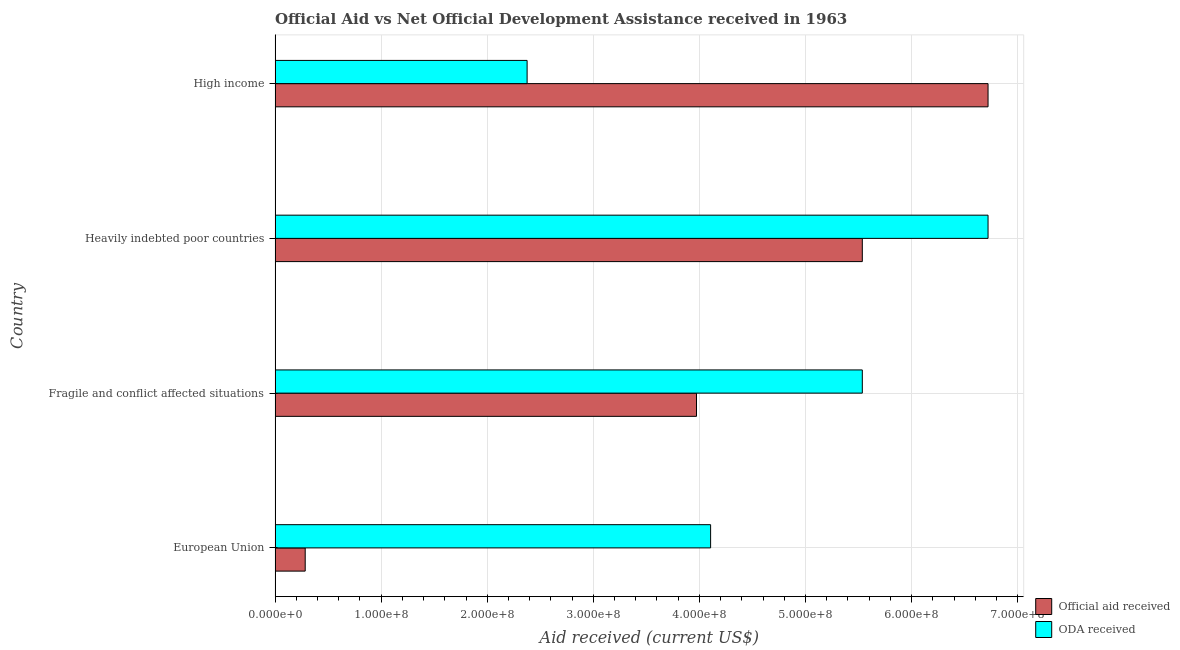How many groups of bars are there?
Your response must be concise. 4. How many bars are there on the 2nd tick from the top?
Give a very brief answer. 2. What is the label of the 3rd group of bars from the top?
Ensure brevity in your answer.  Fragile and conflict affected situations. In how many cases, is the number of bars for a given country not equal to the number of legend labels?
Your answer should be very brief. 0. What is the official aid received in Fragile and conflict affected situations?
Provide a succinct answer. 3.97e+08. Across all countries, what is the maximum oda received?
Offer a terse response. 6.72e+08. Across all countries, what is the minimum oda received?
Give a very brief answer. 2.38e+08. In which country was the official aid received maximum?
Your answer should be compact. High income. What is the total oda received in the graph?
Give a very brief answer. 1.87e+09. What is the difference between the oda received in Fragile and conflict affected situations and that in Heavily indebted poor countries?
Your answer should be very brief. -1.19e+08. What is the difference between the oda received in Heavily indebted poor countries and the official aid received in Fragile and conflict affected situations?
Your answer should be very brief. 2.75e+08. What is the average official aid received per country?
Offer a terse response. 4.13e+08. What is the difference between the official aid received and oda received in Heavily indebted poor countries?
Provide a short and direct response. -1.19e+08. What is the ratio of the oda received in Fragile and conflict affected situations to that in Heavily indebted poor countries?
Give a very brief answer. 0.82. Is the oda received in Heavily indebted poor countries less than that in High income?
Offer a very short reply. No. What is the difference between the highest and the second highest official aid received?
Offer a terse response. 1.19e+08. What is the difference between the highest and the lowest oda received?
Give a very brief answer. 4.34e+08. Is the sum of the oda received in European Union and Heavily indebted poor countries greater than the maximum official aid received across all countries?
Your answer should be very brief. Yes. What does the 2nd bar from the top in High income represents?
Give a very brief answer. Official aid received. What does the 1st bar from the bottom in Fragile and conflict affected situations represents?
Offer a terse response. Official aid received. Are all the bars in the graph horizontal?
Offer a terse response. Yes. How many countries are there in the graph?
Your answer should be very brief. 4. Does the graph contain any zero values?
Provide a succinct answer. No. What is the title of the graph?
Keep it short and to the point. Official Aid vs Net Official Development Assistance received in 1963 . Does "Register a property" appear as one of the legend labels in the graph?
Your answer should be very brief. No. What is the label or title of the X-axis?
Your answer should be very brief. Aid received (current US$). What is the label or title of the Y-axis?
Provide a short and direct response. Country. What is the Aid received (current US$) of Official aid received in European Union?
Offer a terse response. 2.84e+07. What is the Aid received (current US$) in ODA received in European Union?
Ensure brevity in your answer.  4.11e+08. What is the Aid received (current US$) in Official aid received in Fragile and conflict affected situations?
Make the answer very short. 3.97e+08. What is the Aid received (current US$) of ODA received in Fragile and conflict affected situations?
Make the answer very short. 5.54e+08. What is the Aid received (current US$) in Official aid received in Heavily indebted poor countries?
Your answer should be compact. 5.54e+08. What is the Aid received (current US$) in ODA received in Heavily indebted poor countries?
Keep it short and to the point. 6.72e+08. What is the Aid received (current US$) of Official aid received in High income?
Keep it short and to the point. 6.72e+08. What is the Aid received (current US$) in ODA received in High income?
Keep it short and to the point. 2.38e+08. Across all countries, what is the maximum Aid received (current US$) in Official aid received?
Your response must be concise. 6.72e+08. Across all countries, what is the maximum Aid received (current US$) of ODA received?
Ensure brevity in your answer.  6.72e+08. Across all countries, what is the minimum Aid received (current US$) in Official aid received?
Keep it short and to the point. 2.84e+07. Across all countries, what is the minimum Aid received (current US$) of ODA received?
Your answer should be very brief. 2.38e+08. What is the total Aid received (current US$) in Official aid received in the graph?
Give a very brief answer. 1.65e+09. What is the total Aid received (current US$) in ODA received in the graph?
Provide a succinct answer. 1.87e+09. What is the difference between the Aid received (current US$) of Official aid received in European Union and that in Fragile and conflict affected situations?
Your answer should be compact. -3.69e+08. What is the difference between the Aid received (current US$) of ODA received in European Union and that in Fragile and conflict affected situations?
Provide a succinct answer. -1.43e+08. What is the difference between the Aid received (current US$) of Official aid received in European Union and that in Heavily indebted poor countries?
Provide a succinct answer. -5.25e+08. What is the difference between the Aid received (current US$) of ODA received in European Union and that in Heavily indebted poor countries?
Provide a succinct answer. -2.62e+08. What is the difference between the Aid received (current US$) of Official aid received in European Union and that in High income?
Your response must be concise. -6.44e+08. What is the difference between the Aid received (current US$) in ODA received in European Union and that in High income?
Keep it short and to the point. 1.73e+08. What is the difference between the Aid received (current US$) in Official aid received in Fragile and conflict affected situations and that in Heavily indebted poor countries?
Ensure brevity in your answer.  -1.56e+08. What is the difference between the Aid received (current US$) of ODA received in Fragile and conflict affected situations and that in Heavily indebted poor countries?
Give a very brief answer. -1.19e+08. What is the difference between the Aid received (current US$) in Official aid received in Fragile and conflict affected situations and that in High income?
Your answer should be very brief. -2.75e+08. What is the difference between the Aid received (current US$) in ODA received in Fragile and conflict affected situations and that in High income?
Offer a very short reply. 3.16e+08. What is the difference between the Aid received (current US$) in Official aid received in Heavily indebted poor countries and that in High income?
Your answer should be compact. -1.19e+08. What is the difference between the Aid received (current US$) of ODA received in Heavily indebted poor countries and that in High income?
Offer a very short reply. 4.34e+08. What is the difference between the Aid received (current US$) in Official aid received in European Union and the Aid received (current US$) in ODA received in Fragile and conflict affected situations?
Your answer should be very brief. -5.25e+08. What is the difference between the Aid received (current US$) of Official aid received in European Union and the Aid received (current US$) of ODA received in Heavily indebted poor countries?
Give a very brief answer. -6.44e+08. What is the difference between the Aid received (current US$) in Official aid received in European Union and the Aid received (current US$) in ODA received in High income?
Your response must be concise. -2.09e+08. What is the difference between the Aid received (current US$) of Official aid received in Fragile and conflict affected situations and the Aid received (current US$) of ODA received in Heavily indebted poor countries?
Your response must be concise. -2.75e+08. What is the difference between the Aid received (current US$) in Official aid received in Fragile and conflict affected situations and the Aid received (current US$) in ODA received in High income?
Offer a terse response. 1.60e+08. What is the difference between the Aid received (current US$) of Official aid received in Heavily indebted poor countries and the Aid received (current US$) of ODA received in High income?
Provide a succinct answer. 3.16e+08. What is the average Aid received (current US$) in Official aid received per country?
Your response must be concise. 4.13e+08. What is the average Aid received (current US$) of ODA received per country?
Ensure brevity in your answer.  4.68e+08. What is the difference between the Aid received (current US$) of Official aid received and Aid received (current US$) of ODA received in European Union?
Your answer should be very brief. -3.82e+08. What is the difference between the Aid received (current US$) in Official aid received and Aid received (current US$) in ODA received in Fragile and conflict affected situations?
Make the answer very short. -1.56e+08. What is the difference between the Aid received (current US$) in Official aid received and Aid received (current US$) in ODA received in Heavily indebted poor countries?
Your answer should be very brief. -1.19e+08. What is the difference between the Aid received (current US$) of Official aid received and Aid received (current US$) of ODA received in High income?
Make the answer very short. 4.34e+08. What is the ratio of the Aid received (current US$) in Official aid received in European Union to that in Fragile and conflict affected situations?
Keep it short and to the point. 0.07. What is the ratio of the Aid received (current US$) of ODA received in European Union to that in Fragile and conflict affected situations?
Provide a short and direct response. 0.74. What is the ratio of the Aid received (current US$) in Official aid received in European Union to that in Heavily indebted poor countries?
Your answer should be very brief. 0.05. What is the ratio of the Aid received (current US$) in ODA received in European Union to that in Heavily indebted poor countries?
Make the answer very short. 0.61. What is the ratio of the Aid received (current US$) in Official aid received in European Union to that in High income?
Offer a very short reply. 0.04. What is the ratio of the Aid received (current US$) of ODA received in European Union to that in High income?
Offer a very short reply. 1.73. What is the ratio of the Aid received (current US$) in Official aid received in Fragile and conflict affected situations to that in Heavily indebted poor countries?
Provide a short and direct response. 0.72. What is the ratio of the Aid received (current US$) of ODA received in Fragile and conflict affected situations to that in Heavily indebted poor countries?
Give a very brief answer. 0.82. What is the ratio of the Aid received (current US$) of Official aid received in Fragile and conflict affected situations to that in High income?
Offer a very short reply. 0.59. What is the ratio of the Aid received (current US$) of ODA received in Fragile and conflict affected situations to that in High income?
Provide a succinct answer. 2.33. What is the ratio of the Aid received (current US$) in Official aid received in Heavily indebted poor countries to that in High income?
Give a very brief answer. 0.82. What is the ratio of the Aid received (current US$) in ODA received in Heavily indebted poor countries to that in High income?
Your response must be concise. 2.83. What is the difference between the highest and the second highest Aid received (current US$) in Official aid received?
Offer a very short reply. 1.19e+08. What is the difference between the highest and the second highest Aid received (current US$) in ODA received?
Offer a terse response. 1.19e+08. What is the difference between the highest and the lowest Aid received (current US$) in Official aid received?
Your answer should be very brief. 6.44e+08. What is the difference between the highest and the lowest Aid received (current US$) of ODA received?
Provide a succinct answer. 4.34e+08. 